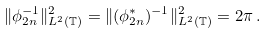Convert formula to latex. <formula><loc_0><loc_0><loc_500><loc_500>\| \phi _ { 2 n } ^ { - 1 } \| ^ { 2 } _ { L ^ { 2 } ( \mathbb { T } ) } = \| ( \phi _ { 2 n } ^ { * } ) ^ { - 1 } \| ^ { 2 } _ { L ^ { 2 } ( \mathbb { T } ) } = 2 \pi \, .</formula> 